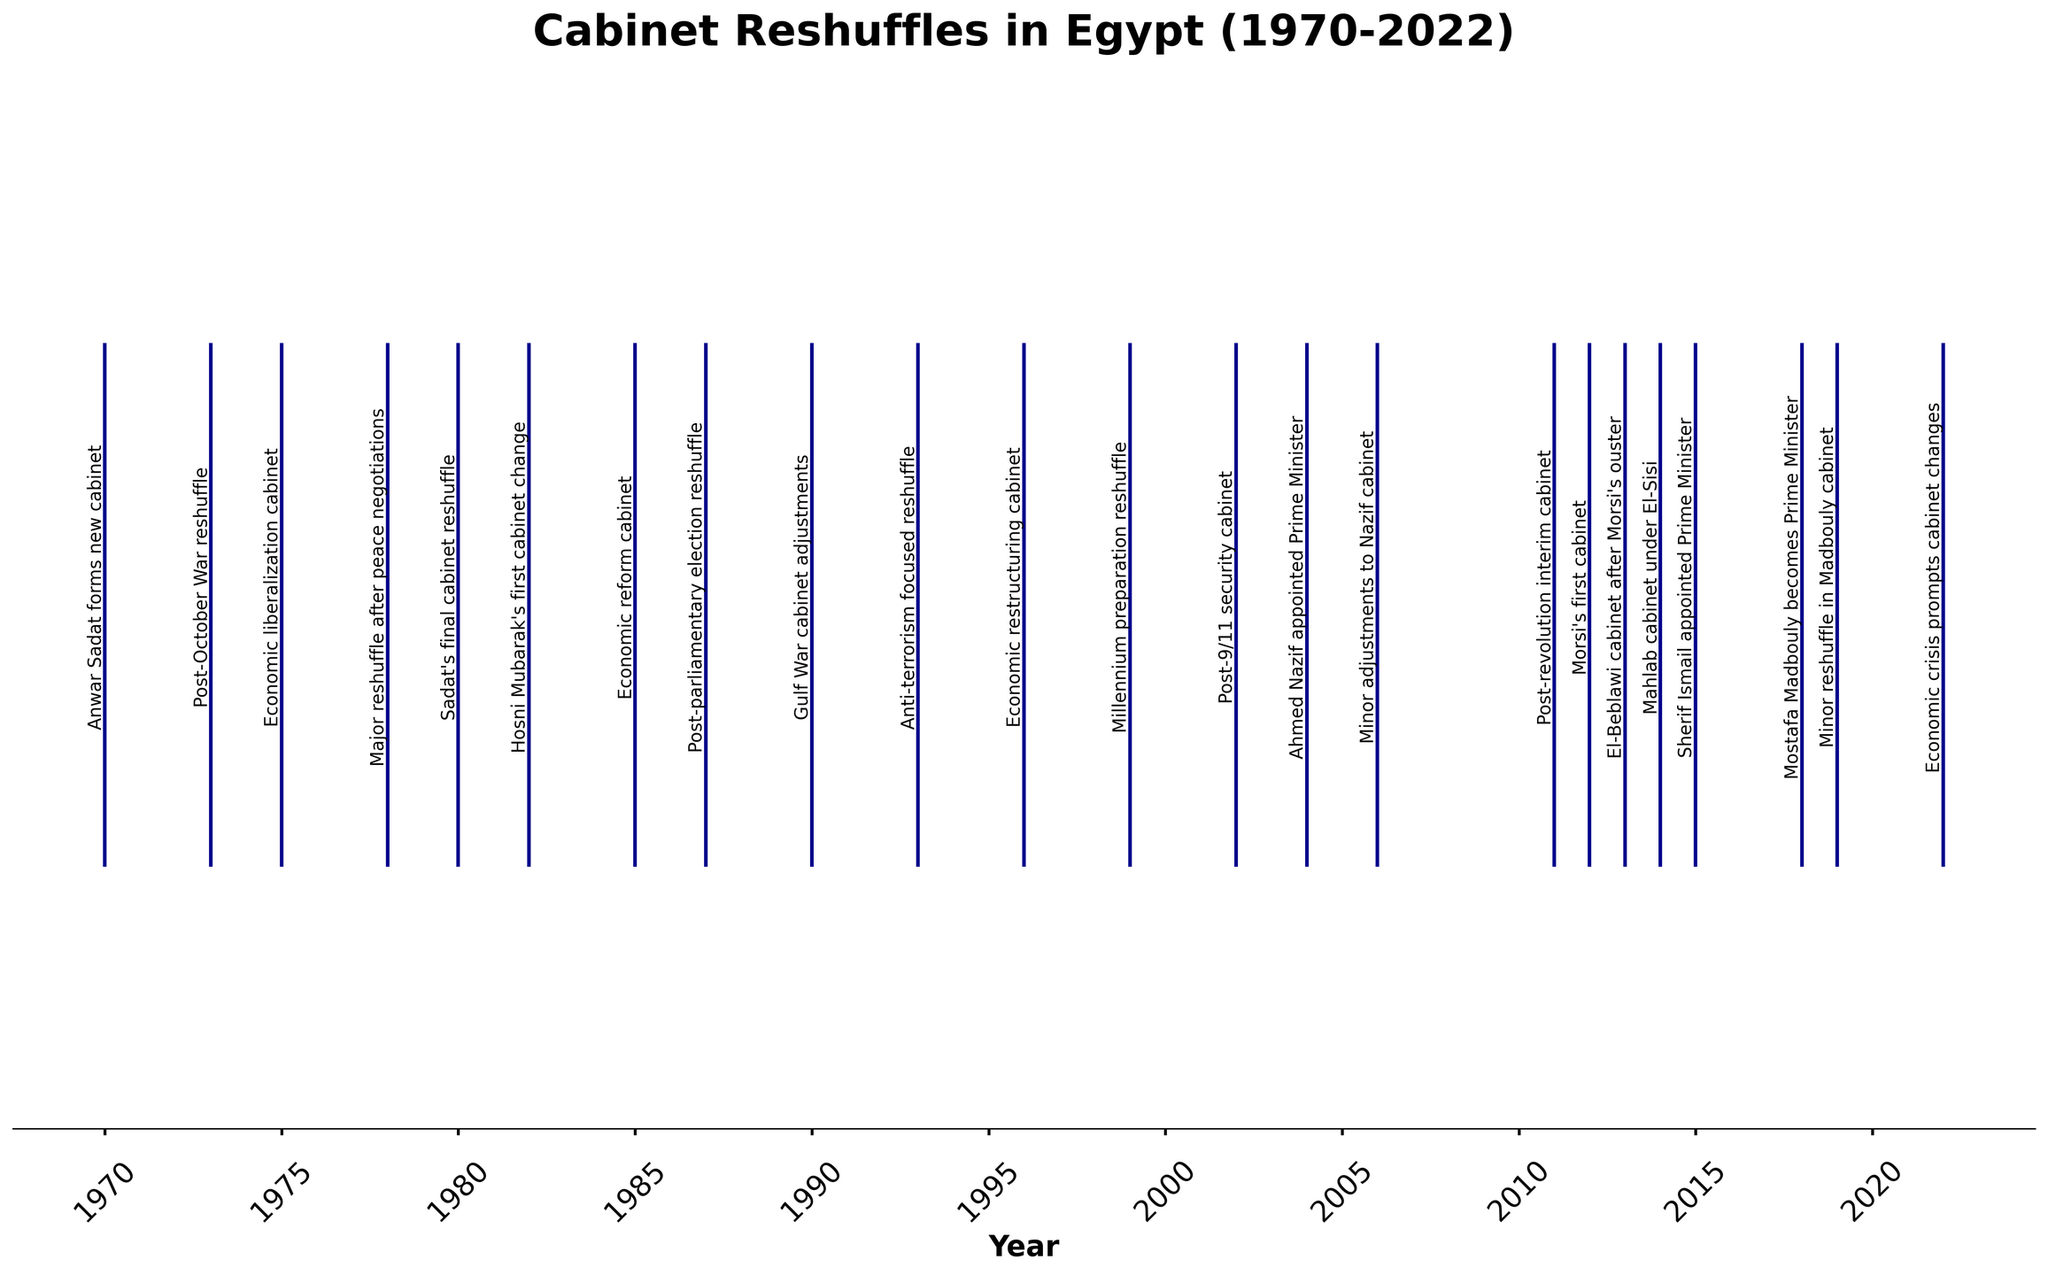What's the title of the figure? The title can be found at the top of the figure. It provides the main subject of the visualization.
Answer: Cabinet Reshuffles in Egypt (1970-2022) What does the x-axis represent? The x-axis labels represent the years over which the cabinet reshuffles took place, as indicated by the time-based labels on the axis.
Answer: Year How many cabinet reshuffles occurred during the 1980s according to the figure? To find this, locate the years between 1980 and 1989 on the x-axis and count the events marked in this range.
Answer: 3 Which year had the reshuffle named “Mahlab cabinet under El-Sisi"? Identify the event with this name and trace it back to the respective year on the x-axis.
Answer: 2014 Compare the number of cabinet reshuffles in the 1970s to those in the 2010s. Which decade had more reshuffles? Count the number of events between 1970-1979 and compare it with the events between 2010-2019. The decade with the higher count has more reshuffles.
Answer: 2010s Was there a cabinet reshuffle in 2000? Check the x-axis for the year 2000 and see if there is a corresponding event marker.
Answer: No What event took place during 2011 as per the figure? Locate the year 2011 on the x-axis and find the associated annotation for that year.
Answer: Post-revolution interim cabinet How often do the major cabinet reshuffles tend to occur between 1990 and 2010? Count the number of event markers between 1990 and 2010 and divide by the number of years (20 years) to determine the average frequency.
Answer: About every 2 years Which Prime Minister was appointed in 2015? Find the annotation for the year 2015 on the figure and read the event description.
Answer: Sherif Ismail Which reshuffle came immediately after the “Economic reform cabinet” in 1985? Identify the "Economic reform cabinet" event on the timeline, then look for the next event chronologically.
Answer: Post-parliamentary election reshuffle in 1987 